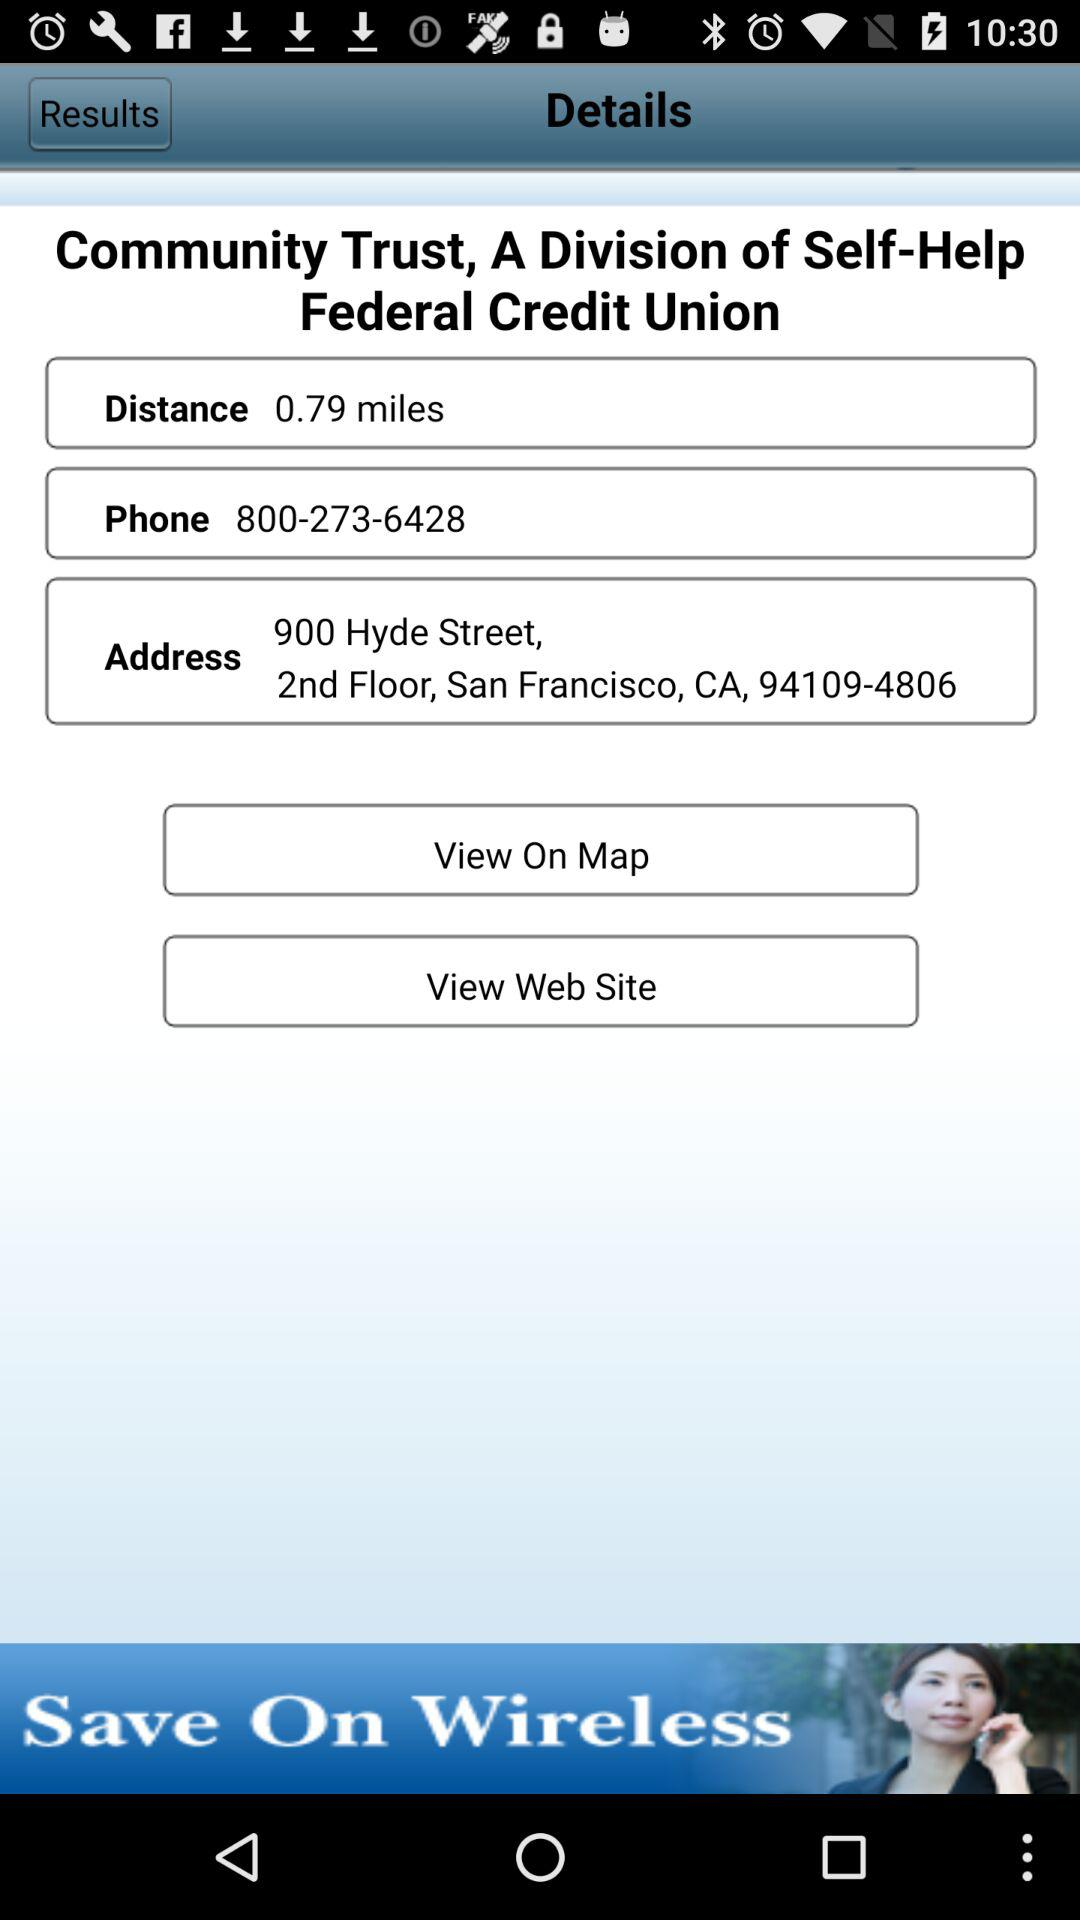What is the phone number? The phone number is 800-273-6428. 